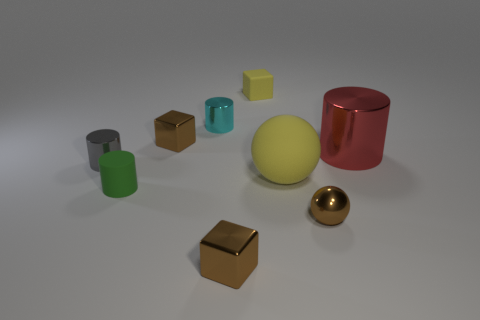There is a tiny brown thing that is in front of the large matte sphere and on the left side of the tiny matte cube; what is its shape?
Ensure brevity in your answer.  Cube. There is a small rubber object behind the matte object left of the brown shiny cube in front of the green matte cylinder; what is its color?
Ensure brevity in your answer.  Yellow. Are there more small objects that are to the left of the large rubber sphere than tiny gray things in front of the small yellow matte thing?
Give a very brief answer. Yes. What number of other things are the same size as the yellow cube?
Keep it short and to the point. 6. There is a matte thing that is the same color as the matte block; what size is it?
Provide a short and direct response. Large. The brown thing right of the small rubber object to the right of the tiny cyan metal cylinder is made of what material?
Ensure brevity in your answer.  Metal. There is a tiny gray metal cylinder; are there any tiny green things behind it?
Make the answer very short. No. Is the number of cyan cylinders in front of the small yellow block greater than the number of tiny cyan shiny cylinders?
Offer a very short reply. No. Is there a rubber thing that has the same color as the metallic sphere?
Your answer should be compact. No. What is the color of the sphere that is the same size as the cyan metal cylinder?
Give a very brief answer. Brown. 